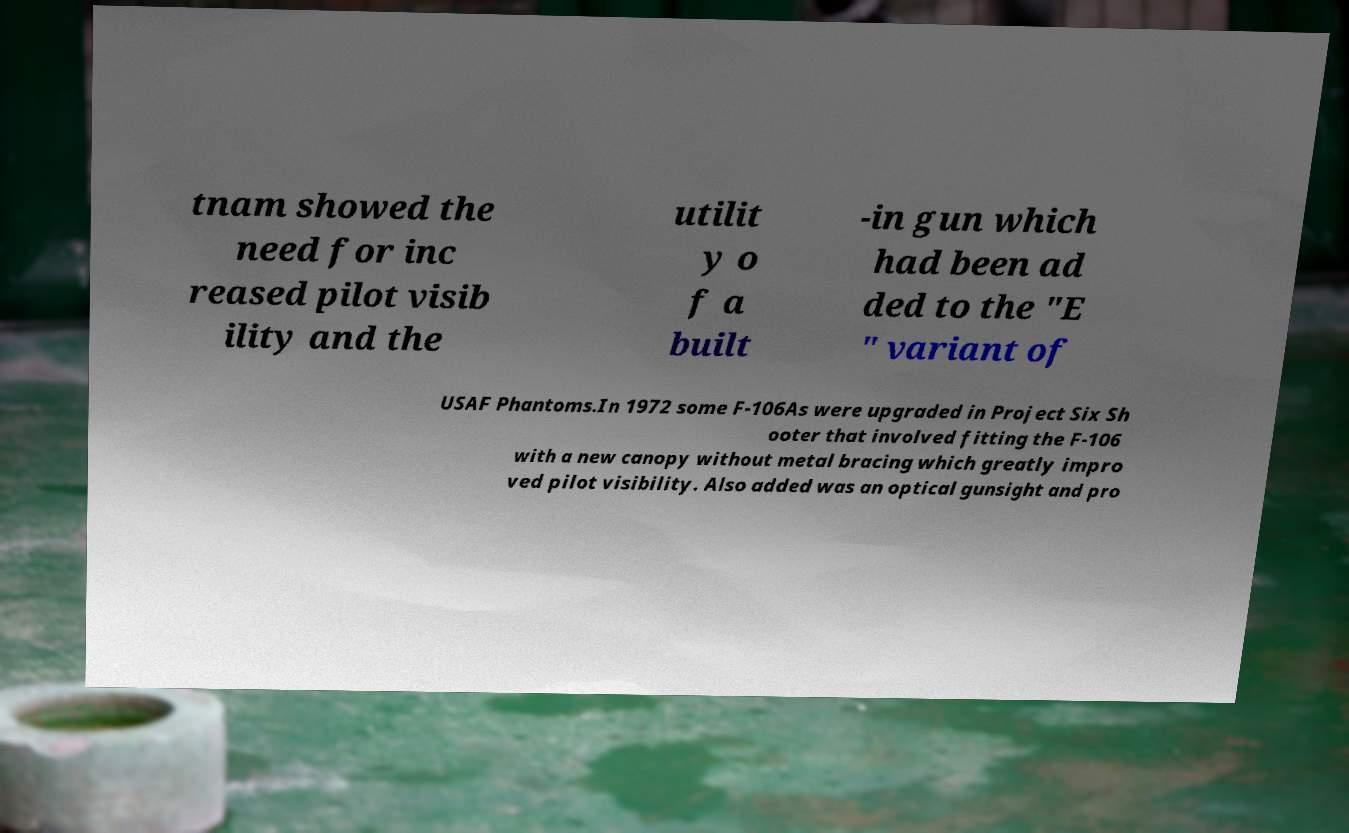Can you accurately transcribe the text from the provided image for me? tnam showed the need for inc reased pilot visib ility and the utilit y o f a built -in gun which had been ad ded to the "E " variant of USAF Phantoms.In 1972 some F-106As were upgraded in Project Six Sh ooter that involved fitting the F-106 with a new canopy without metal bracing which greatly impro ved pilot visibility. Also added was an optical gunsight and pro 